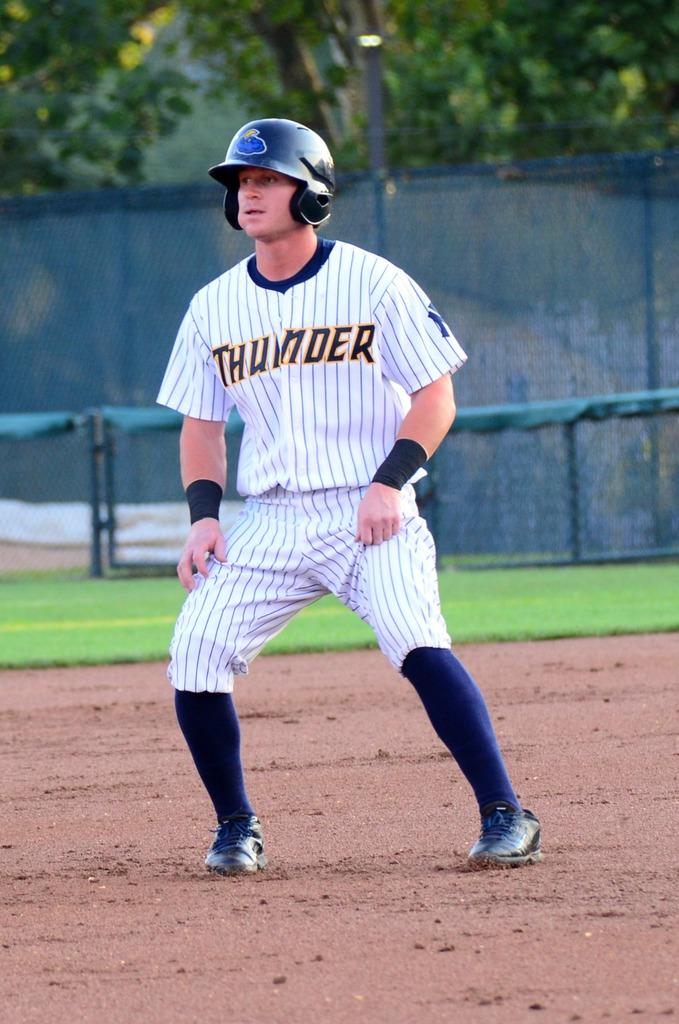<image>
Describe the image concisely. A man gets ready to run in a Thunder baseball uniform. 